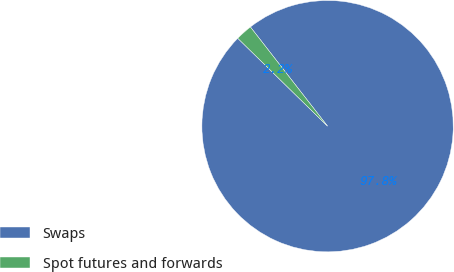Convert chart to OTSL. <chart><loc_0><loc_0><loc_500><loc_500><pie_chart><fcel>Swaps<fcel>Spot futures and forwards<nl><fcel>97.85%<fcel>2.15%<nl></chart> 